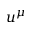Convert formula to latex. <formula><loc_0><loc_0><loc_500><loc_500>u ^ { \mu }</formula> 